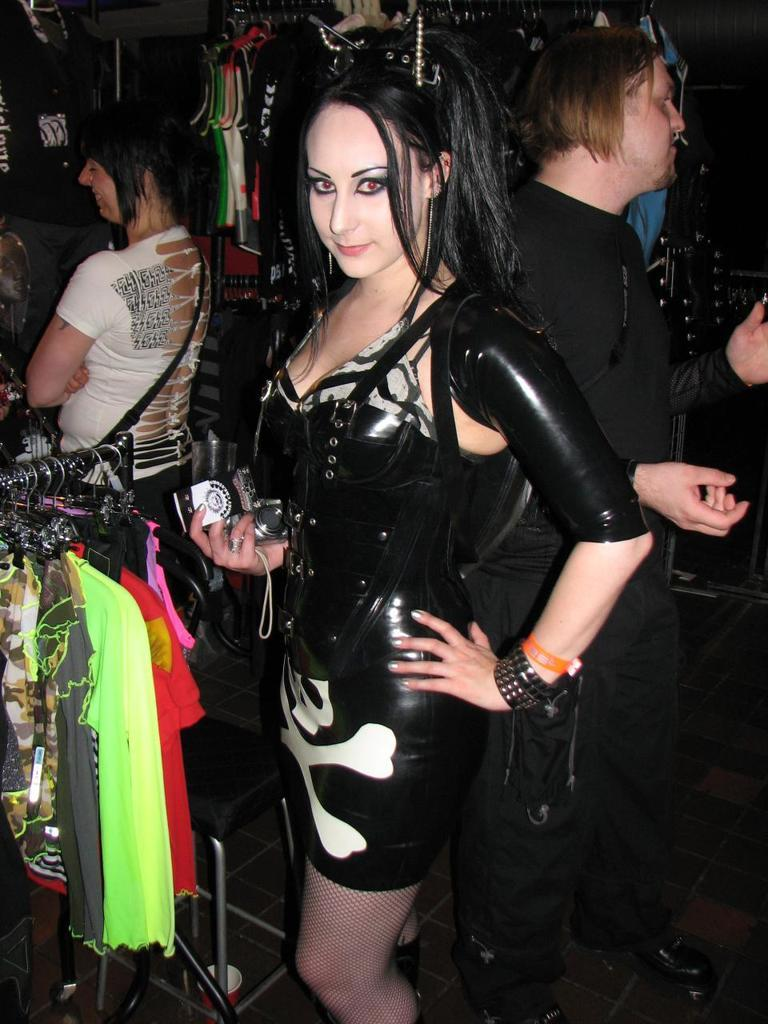What is the woman in the image doing? The woman is standing in the image and holding a camera. What can be seen hanging in the image? There are clothes hanged on clothes hangers in the image. Are there any other people present in the image? Yes, there are people standing in the image. What type of poison is the woman using to take pictures in the image? There is no poison present in the image, and the woman is not using any poison to take pictures. 